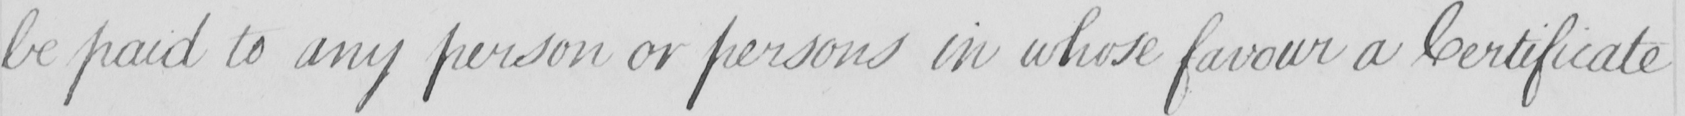What text is written in this handwritten line? be paid to any person or persons in whose favour a Certificate 